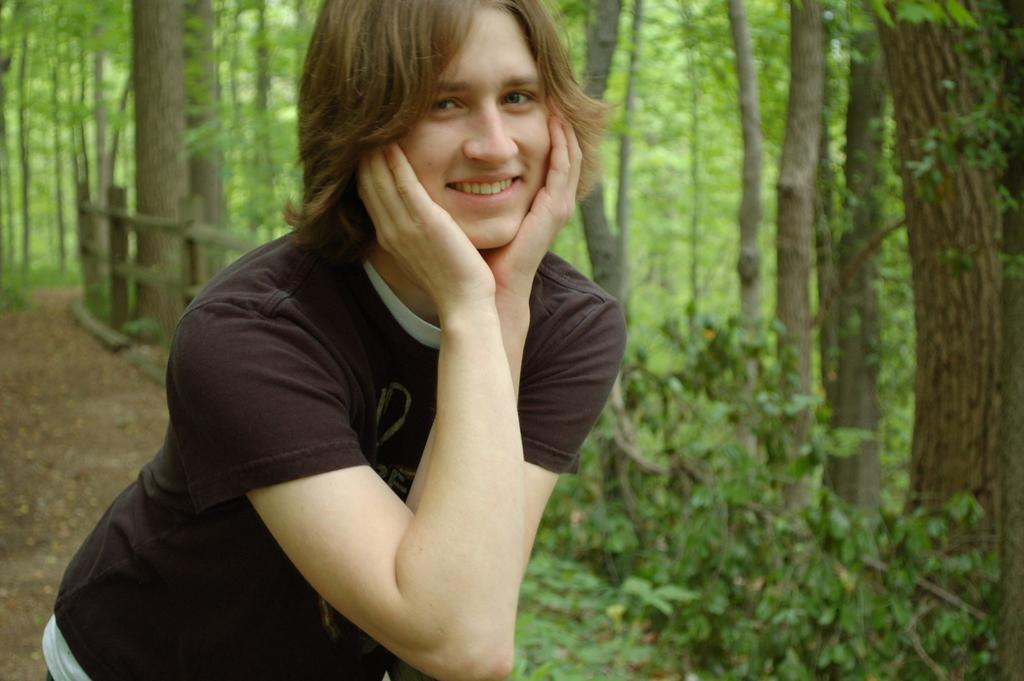Who or what is present in the image? There is a person in the image. What is the person wearing? The person is wearing a black t-shirt. What can be seen in the background of the image? There are trees and a fencing in the background of the image. What type of payment method is being used by the person in the image? There is no indication of any payment method being used in the image, as it only features a person wearing a black t-shirt with trees and a fencing in the background. 